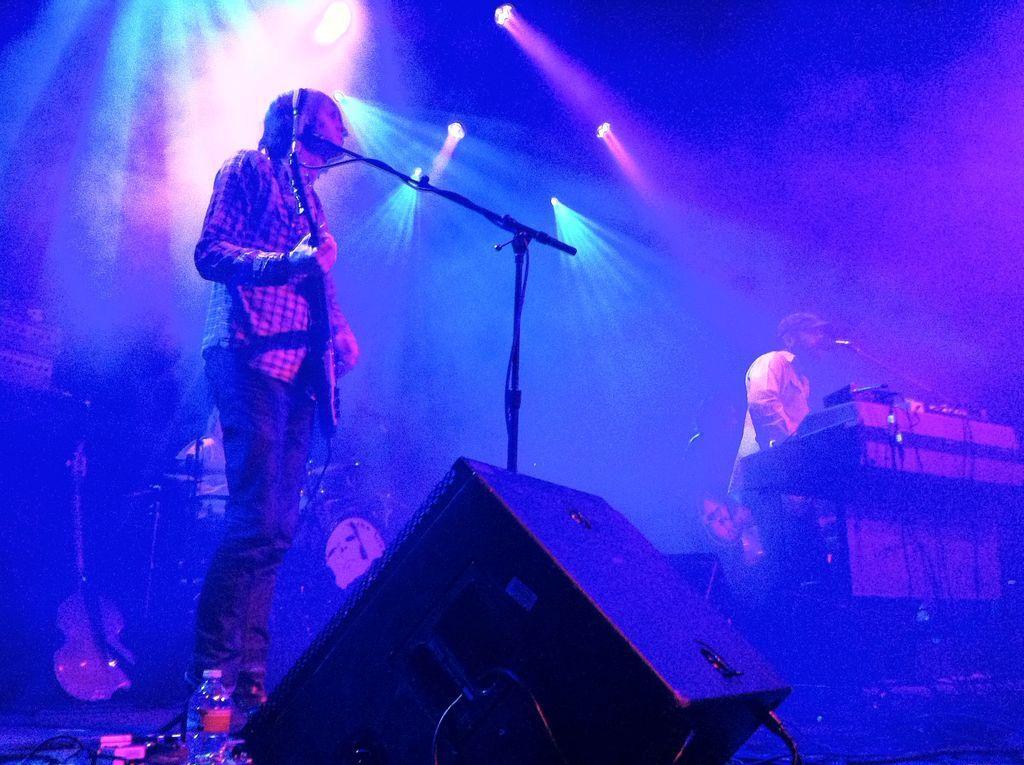In one or two sentences, can you explain what this image depicts? This picture is clicked in the musical concert. At the bottom, we see a water bottle, speaker box and the wires. The man on the left side is standing and he is holding a guitar in his hand. In front of him, we see a microphone. Behind him, we see a guitar and some musical instruments. On the right side, we see a man is standing. In front of him, we see the musical instruments and a microphone. He might be singing the song on the microphone. At the top, we see the lights. In the background, it is blue in color. 